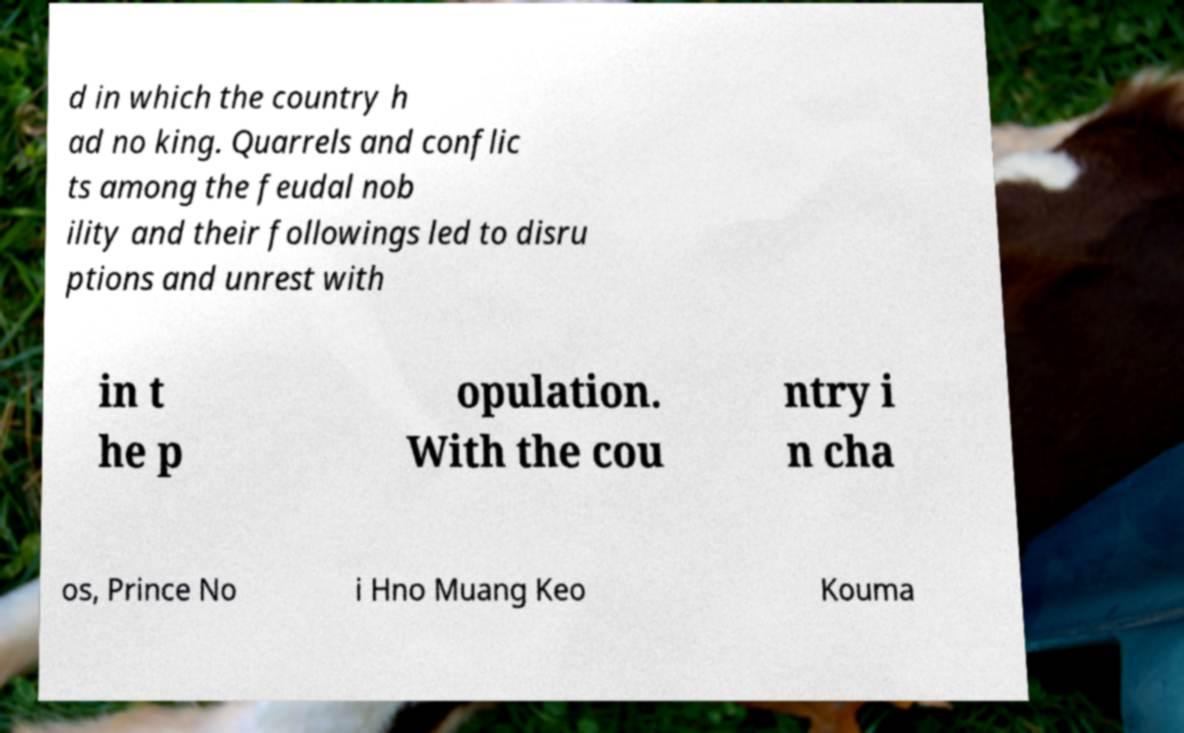Could you extract and type out the text from this image? d in which the country h ad no king. Quarrels and conflic ts among the feudal nob ility and their followings led to disru ptions and unrest with in t he p opulation. With the cou ntry i n cha os, Prince No i Hno Muang Keo Kouma 